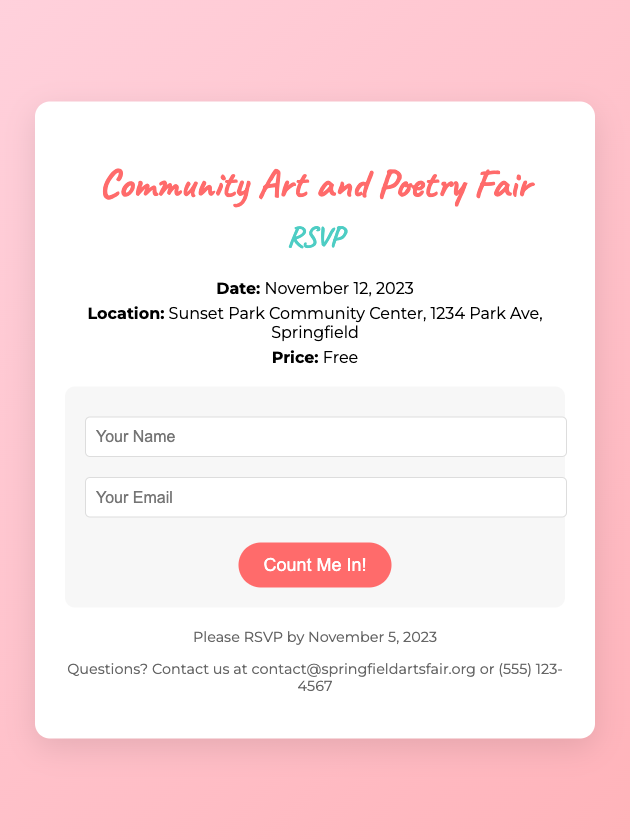What is the date of the fair? The date of the fair is mentioned as November 12, 2023, in the document.
Answer: November 12, 2023 Where is the event located? The location of the event is specified as Sunset Park Community Center, 1234 Park Ave, Springfield.
Answer: Sunset Park Community Center, 1234 Park Ave, Springfield What is the price of admission? The price for attending the event is stated as Free in the document.
Answer: Free When is the RSVP deadline? The document indicates that RSVPs should be submitted by November 5, 2023.
Answer: November 5, 2023 What should I include in the RSVP form? The RSVP form requires your Name and Email as indicated in the document.
Answer: Name and Email What is the contact information for questions? The document provides contact details as contact@springfieldartsfair.org or (555) 123-4567.
Answer: contact@springfieldartsfair.org or (555) 123-4567 Is this event suitable for all ages? The document does not specify an age restriction, but mentions general community participation, suggesting it is suitable for all ages.
Answer: Yes What type of event is this? The event is categorized as a Community Art and Poetry Fair, as stated in the title.
Answer: Community Art and Poetry Fair 